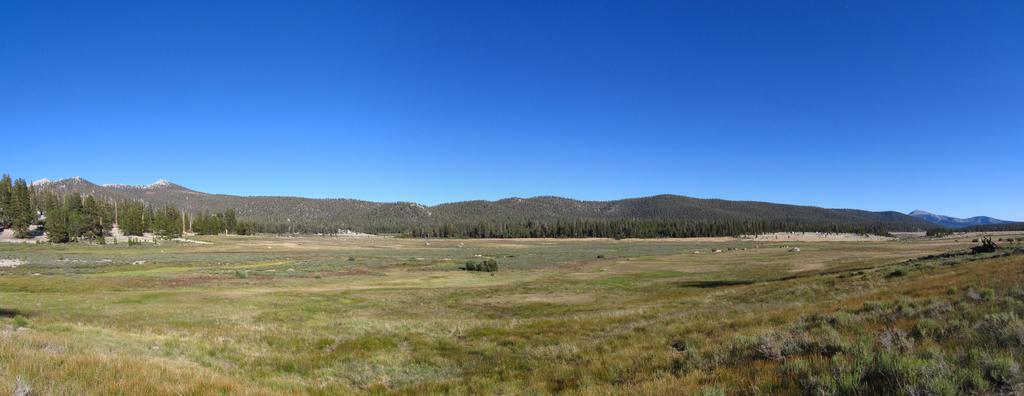What type of natural landscape can be seen in the image? The image features hills, trees, and grass, which are all part of a natural landscape. Are there any large landforms visible in the image? Yes, there are mountains in the image. What is visible in the sky in the image? The sky is visible in the image. Can you see any flowers growing in the grass in the image? There is no mention of flowers in the provided facts, so we cannot determine if any are present in the image. --- Facts: 1. There is a person holding a book in the image. 2. The person is sitting on a chair. 3. There is a table in the image. 4. The table has a lamp on it. 5. The background of the image is a room. Absurd Topics: parrot, ocean, bicycle Conversation: What is the person in the image doing? The person is holding a book in the image. Where is the person sitting? The person is sitting on a chair. What is on the table in the image? The table has a lamp on it. What is the setting of the image? The background of the image is a room. Reasoning: Let's think step by step in order to produce the conversation. We start by identifying the main action of the person in the image, which is holding a book. Then, we describe the person's position, noting that they are sitting on a chair. Next, we mention the presence of a table and its contents, which include a lamp. Finally, we establish the setting of the image, which is a room. Absurd Question/Answer: Can you see a parrot flying in the room in the image? There is no mention of a parrot in the provided facts, so we cannot determine if one is present in the image. 